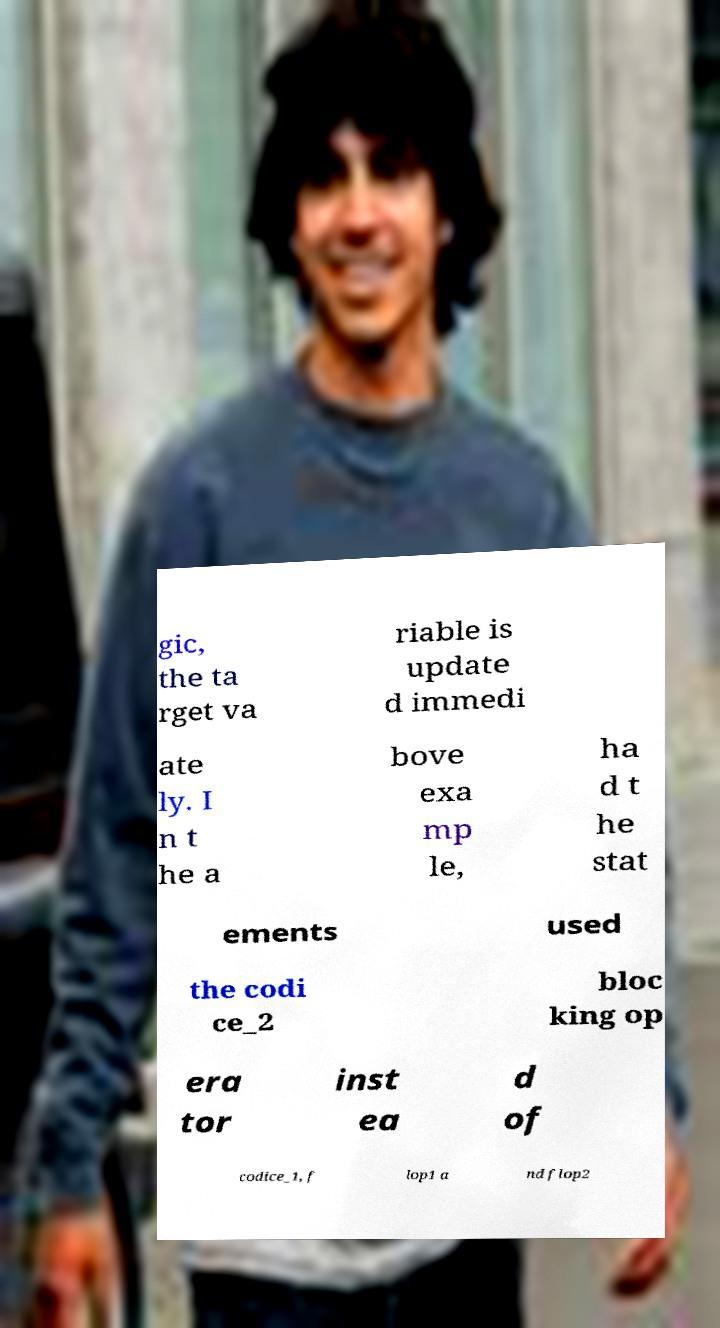There's text embedded in this image that I need extracted. Can you transcribe it verbatim? gic, the ta rget va riable is update d immedi ate ly. I n t he a bove exa mp le, ha d t he stat ements used the codi ce_2 bloc king op era tor inst ea d of codice_1, f lop1 a nd flop2 